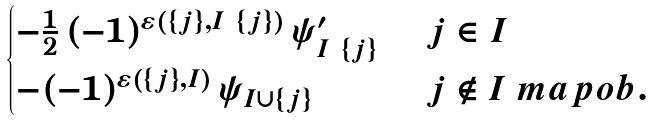Convert formula to latex. <formula><loc_0><loc_0><loc_500><loc_500>\begin{cases} - \frac { 1 } { 2 } \, ( - 1 ) ^ { \varepsilon ( \{ j \} , I \ \{ j \} ) } \, \psi ^ { \prime } _ { I \ \{ j \} } & \ j \in I \\ - ( - 1 ) ^ { \varepsilon ( \{ j \} , I ) } \, \psi _ { I \cup \{ j \} } & \ j \notin I \ m a p o b . \end{cases}</formula> 